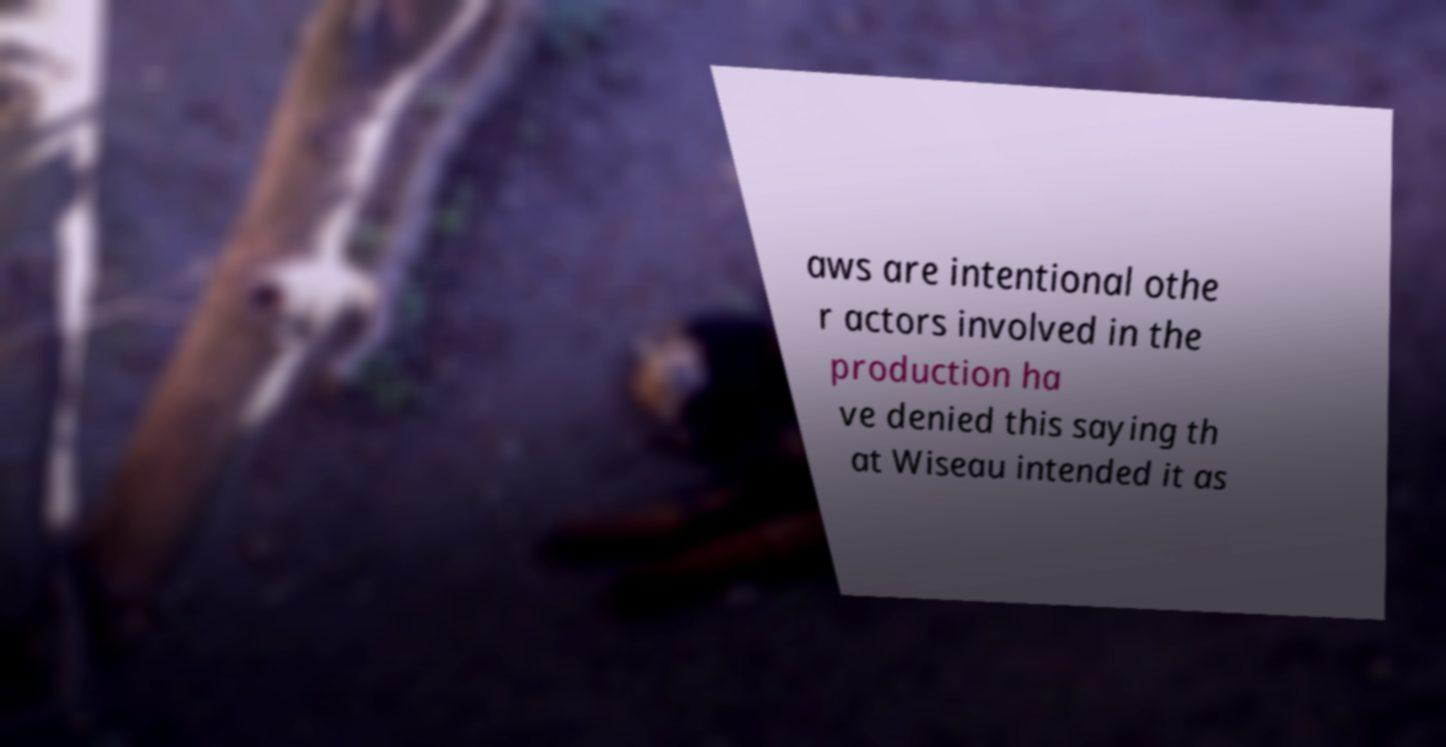I need the written content from this picture converted into text. Can you do that? aws are intentional othe r actors involved in the production ha ve denied this saying th at Wiseau intended it as 